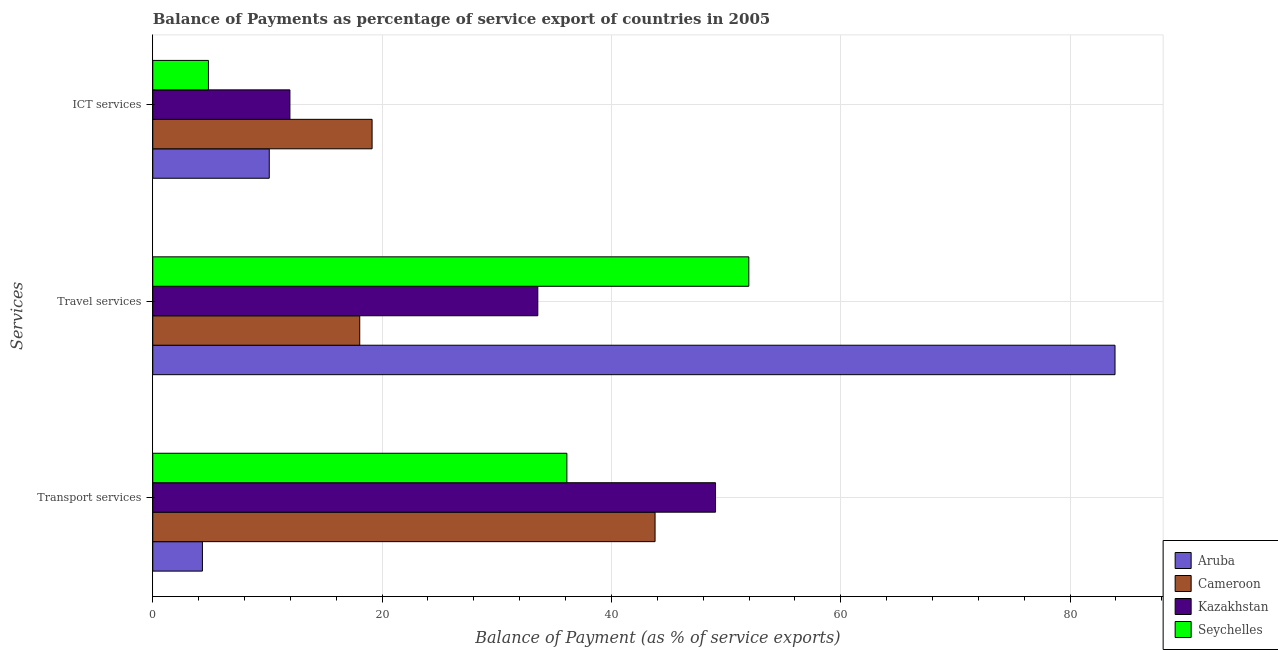How many different coloured bars are there?
Provide a short and direct response. 4. Are the number of bars per tick equal to the number of legend labels?
Your answer should be compact. Yes. Are the number of bars on each tick of the Y-axis equal?
Ensure brevity in your answer.  Yes. How many bars are there on the 1st tick from the top?
Provide a succinct answer. 4. What is the label of the 2nd group of bars from the top?
Provide a succinct answer. Travel services. What is the balance of payment of travel services in Cameroon?
Your response must be concise. 18.05. Across all countries, what is the maximum balance of payment of transport services?
Offer a very short reply. 49.08. Across all countries, what is the minimum balance of payment of ict services?
Your answer should be very brief. 4.85. In which country was the balance of payment of travel services maximum?
Keep it short and to the point. Aruba. In which country was the balance of payment of transport services minimum?
Provide a short and direct response. Aruba. What is the total balance of payment of ict services in the graph?
Give a very brief answer. 46.1. What is the difference between the balance of payment of travel services in Kazakhstan and that in Aruba?
Provide a succinct answer. -50.34. What is the difference between the balance of payment of travel services in Cameroon and the balance of payment of transport services in Kazakhstan?
Your answer should be very brief. -31.03. What is the average balance of payment of travel services per country?
Your answer should be very brief. 46.88. What is the difference between the balance of payment of ict services and balance of payment of transport services in Kazakhstan?
Make the answer very short. -37.12. What is the ratio of the balance of payment of travel services in Kazakhstan to that in Seychelles?
Your response must be concise. 0.65. Is the balance of payment of travel services in Kazakhstan less than that in Seychelles?
Your response must be concise. Yes. What is the difference between the highest and the second highest balance of payment of transport services?
Your answer should be very brief. 5.27. What is the difference between the highest and the lowest balance of payment of transport services?
Your response must be concise. 44.75. What does the 1st bar from the top in ICT services represents?
Your answer should be very brief. Seychelles. What does the 3rd bar from the bottom in Transport services represents?
Provide a succinct answer. Kazakhstan. Is it the case that in every country, the sum of the balance of payment of transport services and balance of payment of travel services is greater than the balance of payment of ict services?
Make the answer very short. Yes. How many bars are there?
Give a very brief answer. 12. Are all the bars in the graph horizontal?
Provide a succinct answer. Yes. What is the difference between two consecutive major ticks on the X-axis?
Provide a short and direct response. 20. Are the values on the major ticks of X-axis written in scientific E-notation?
Ensure brevity in your answer.  No. Does the graph contain grids?
Your answer should be very brief. Yes. Where does the legend appear in the graph?
Your response must be concise. Bottom right. How are the legend labels stacked?
Offer a very short reply. Vertical. What is the title of the graph?
Your answer should be compact. Balance of Payments as percentage of service export of countries in 2005. Does "Somalia" appear as one of the legend labels in the graph?
Your response must be concise. No. What is the label or title of the X-axis?
Your answer should be very brief. Balance of Payment (as % of service exports). What is the label or title of the Y-axis?
Offer a terse response. Services. What is the Balance of Payment (as % of service exports) of Aruba in Transport services?
Offer a very short reply. 4.33. What is the Balance of Payment (as % of service exports) of Cameroon in Transport services?
Keep it short and to the point. 43.8. What is the Balance of Payment (as % of service exports) of Kazakhstan in Transport services?
Provide a succinct answer. 49.08. What is the Balance of Payment (as % of service exports) of Seychelles in Transport services?
Your response must be concise. 36.11. What is the Balance of Payment (as % of service exports) of Aruba in Travel services?
Your answer should be compact. 83.92. What is the Balance of Payment (as % of service exports) in Cameroon in Travel services?
Offer a terse response. 18.05. What is the Balance of Payment (as % of service exports) of Kazakhstan in Travel services?
Ensure brevity in your answer.  33.58. What is the Balance of Payment (as % of service exports) in Seychelles in Travel services?
Give a very brief answer. 51.98. What is the Balance of Payment (as % of service exports) in Aruba in ICT services?
Ensure brevity in your answer.  10.16. What is the Balance of Payment (as % of service exports) of Cameroon in ICT services?
Your answer should be compact. 19.13. What is the Balance of Payment (as % of service exports) of Kazakhstan in ICT services?
Provide a succinct answer. 11.96. What is the Balance of Payment (as % of service exports) of Seychelles in ICT services?
Keep it short and to the point. 4.85. Across all Services, what is the maximum Balance of Payment (as % of service exports) of Aruba?
Provide a succinct answer. 83.92. Across all Services, what is the maximum Balance of Payment (as % of service exports) in Cameroon?
Offer a terse response. 43.8. Across all Services, what is the maximum Balance of Payment (as % of service exports) in Kazakhstan?
Provide a short and direct response. 49.08. Across all Services, what is the maximum Balance of Payment (as % of service exports) in Seychelles?
Provide a succinct answer. 51.98. Across all Services, what is the minimum Balance of Payment (as % of service exports) of Aruba?
Provide a short and direct response. 4.33. Across all Services, what is the minimum Balance of Payment (as % of service exports) in Cameroon?
Ensure brevity in your answer.  18.05. Across all Services, what is the minimum Balance of Payment (as % of service exports) of Kazakhstan?
Provide a succinct answer. 11.96. Across all Services, what is the minimum Balance of Payment (as % of service exports) in Seychelles?
Make the answer very short. 4.85. What is the total Balance of Payment (as % of service exports) in Aruba in the graph?
Make the answer very short. 98.4. What is the total Balance of Payment (as % of service exports) of Cameroon in the graph?
Give a very brief answer. 80.98. What is the total Balance of Payment (as % of service exports) in Kazakhstan in the graph?
Offer a very short reply. 94.62. What is the total Balance of Payment (as % of service exports) of Seychelles in the graph?
Offer a very short reply. 92.95. What is the difference between the Balance of Payment (as % of service exports) in Aruba in Transport services and that in Travel services?
Your answer should be very brief. -79.59. What is the difference between the Balance of Payment (as % of service exports) of Cameroon in Transport services and that in Travel services?
Your answer should be compact. 25.76. What is the difference between the Balance of Payment (as % of service exports) in Seychelles in Transport services and that in Travel services?
Keep it short and to the point. -15.87. What is the difference between the Balance of Payment (as % of service exports) in Aruba in Transport services and that in ICT services?
Your answer should be very brief. -5.83. What is the difference between the Balance of Payment (as % of service exports) of Cameroon in Transport services and that in ICT services?
Provide a short and direct response. 24.68. What is the difference between the Balance of Payment (as % of service exports) of Kazakhstan in Transport services and that in ICT services?
Your answer should be compact. 37.12. What is the difference between the Balance of Payment (as % of service exports) of Seychelles in Transport services and that in ICT services?
Ensure brevity in your answer.  31.26. What is the difference between the Balance of Payment (as % of service exports) in Aruba in Travel services and that in ICT services?
Your answer should be compact. 73.76. What is the difference between the Balance of Payment (as % of service exports) of Cameroon in Travel services and that in ICT services?
Give a very brief answer. -1.08. What is the difference between the Balance of Payment (as % of service exports) in Kazakhstan in Travel services and that in ICT services?
Provide a short and direct response. 21.62. What is the difference between the Balance of Payment (as % of service exports) of Seychelles in Travel services and that in ICT services?
Offer a terse response. 47.12. What is the difference between the Balance of Payment (as % of service exports) of Aruba in Transport services and the Balance of Payment (as % of service exports) of Cameroon in Travel services?
Provide a succinct answer. -13.72. What is the difference between the Balance of Payment (as % of service exports) of Aruba in Transport services and the Balance of Payment (as % of service exports) of Kazakhstan in Travel services?
Your response must be concise. -29.25. What is the difference between the Balance of Payment (as % of service exports) of Aruba in Transport services and the Balance of Payment (as % of service exports) of Seychelles in Travel services?
Your answer should be compact. -47.65. What is the difference between the Balance of Payment (as % of service exports) in Cameroon in Transport services and the Balance of Payment (as % of service exports) in Kazakhstan in Travel services?
Provide a succinct answer. 10.23. What is the difference between the Balance of Payment (as % of service exports) of Cameroon in Transport services and the Balance of Payment (as % of service exports) of Seychelles in Travel services?
Give a very brief answer. -8.18. What is the difference between the Balance of Payment (as % of service exports) of Kazakhstan in Transport services and the Balance of Payment (as % of service exports) of Seychelles in Travel services?
Your answer should be compact. -2.9. What is the difference between the Balance of Payment (as % of service exports) of Aruba in Transport services and the Balance of Payment (as % of service exports) of Cameroon in ICT services?
Make the answer very short. -14.8. What is the difference between the Balance of Payment (as % of service exports) of Aruba in Transport services and the Balance of Payment (as % of service exports) of Kazakhstan in ICT services?
Your response must be concise. -7.63. What is the difference between the Balance of Payment (as % of service exports) of Aruba in Transport services and the Balance of Payment (as % of service exports) of Seychelles in ICT services?
Provide a short and direct response. -0.53. What is the difference between the Balance of Payment (as % of service exports) of Cameroon in Transport services and the Balance of Payment (as % of service exports) of Kazakhstan in ICT services?
Provide a short and direct response. 31.84. What is the difference between the Balance of Payment (as % of service exports) of Cameroon in Transport services and the Balance of Payment (as % of service exports) of Seychelles in ICT services?
Offer a very short reply. 38.95. What is the difference between the Balance of Payment (as % of service exports) of Kazakhstan in Transport services and the Balance of Payment (as % of service exports) of Seychelles in ICT services?
Provide a short and direct response. 44.22. What is the difference between the Balance of Payment (as % of service exports) in Aruba in Travel services and the Balance of Payment (as % of service exports) in Cameroon in ICT services?
Provide a succinct answer. 64.79. What is the difference between the Balance of Payment (as % of service exports) in Aruba in Travel services and the Balance of Payment (as % of service exports) in Kazakhstan in ICT services?
Ensure brevity in your answer.  71.96. What is the difference between the Balance of Payment (as % of service exports) of Aruba in Travel services and the Balance of Payment (as % of service exports) of Seychelles in ICT services?
Your answer should be very brief. 79.06. What is the difference between the Balance of Payment (as % of service exports) of Cameroon in Travel services and the Balance of Payment (as % of service exports) of Kazakhstan in ICT services?
Your response must be concise. 6.09. What is the difference between the Balance of Payment (as % of service exports) in Cameroon in Travel services and the Balance of Payment (as % of service exports) in Seychelles in ICT services?
Provide a short and direct response. 13.19. What is the difference between the Balance of Payment (as % of service exports) in Kazakhstan in Travel services and the Balance of Payment (as % of service exports) in Seychelles in ICT services?
Provide a short and direct response. 28.72. What is the average Balance of Payment (as % of service exports) of Aruba per Services?
Give a very brief answer. 32.8. What is the average Balance of Payment (as % of service exports) in Cameroon per Services?
Ensure brevity in your answer.  26.99. What is the average Balance of Payment (as % of service exports) in Kazakhstan per Services?
Provide a succinct answer. 31.54. What is the average Balance of Payment (as % of service exports) in Seychelles per Services?
Give a very brief answer. 30.98. What is the difference between the Balance of Payment (as % of service exports) of Aruba and Balance of Payment (as % of service exports) of Cameroon in Transport services?
Keep it short and to the point. -39.47. What is the difference between the Balance of Payment (as % of service exports) of Aruba and Balance of Payment (as % of service exports) of Kazakhstan in Transport services?
Your response must be concise. -44.75. What is the difference between the Balance of Payment (as % of service exports) of Aruba and Balance of Payment (as % of service exports) of Seychelles in Transport services?
Make the answer very short. -31.78. What is the difference between the Balance of Payment (as % of service exports) in Cameroon and Balance of Payment (as % of service exports) in Kazakhstan in Transport services?
Offer a terse response. -5.27. What is the difference between the Balance of Payment (as % of service exports) of Cameroon and Balance of Payment (as % of service exports) of Seychelles in Transport services?
Provide a succinct answer. 7.69. What is the difference between the Balance of Payment (as % of service exports) of Kazakhstan and Balance of Payment (as % of service exports) of Seychelles in Transport services?
Your answer should be very brief. 12.96. What is the difference between the Balance of Payment (as % of service exports) of Aruba and Balance of Payment (as % of service exports) of Cameroon in Travel services?
Provide a succinct answer. 65.87. What is the difference between the Balance of Payment (as % of service exports) of Aruba and Balance of Payment (as % of service exports) of Kazakhstan in Travel services?
Your answer should be very brief. 50.34. What is the difference between the Balance of Payment (as % of service exports) of Aruba and Balance of Payment (as % of service exports) of Seychelles in Travel services?
Give a very brief answer. 31.94. What is the difference between the Balance of Payment (as % of service exports) of Cameroon and Balance of Payment (as % of service exports) of Kazakhstan in Travel services?
Offer a very short reply. -15.53. What is the difference between the Balance of Payment (as % of service exports) of Cameroon and Balance of Payment (as % of service exports) of Seychelles in Travel services?
Your answer should be compact. -33.93. What is the difference between the Balance of Payment (as % of service exports) of Kazakhstan and Balance of Payment (as % of service exports) of Seychelles in Travel services?
Make the answer very short. -18.4. What is the difference between the Balance of Payment (as % of service exports) in Aruba and Balance of Payment (as % of service exports) in Cameroon in ICT services?
Your answer should be compact. -8.97. What is the difference between the Balance of Payment (as % of service exports) of Aruba and Balance of Payment (as % of service exports) of Kazakhstan in ICT services?
Give a very brief answer. -1.8. What is the difference between the Balance of Payment (as % of service exports) in Aruba and Balance of Payment (as % of service exports) in Seychelles in ICT services?
Provide a succinct answer. 5.3. What is the difference between the Balance of Payment (as % of service exports) in Cameroon and Balance of Payment (as % of service exports) in Kazakhstan in ICT services?
Provide a succinct answer. 7.17. What is the difference between the Balance of Payment (as % of service exports) of Cameroon and Balance of Payment (as % of service exports) of Seychelles in ICT services?
Ensure brevity in your answer.  14.27. What is the difference between the Balance of Payment (as % of service exports) of Kazakhstan and Balance of Payment (as % of service exports) of Seychelles in ICT services?
Ensure brevity in your answer.  7.11. What is the ratio of the Balance of Payment (as % of service exports) of Aruba in Transport services to that in Travel services?
Provide a short and direct response. 0.05. What is the ratio of the Balance of Payment (as % of service exports) in Cameroon in Transport services to that in Travel services?
Make the answer very short. 2.43. What is the ratio of the Balance of Payment (as % of service exports) of Kazakhstan in Transport services to that in Travel services?
Give a very brief answer. 1.46. What is the ratio of the Balance of Payment (as % of service exports) of Seychelles in Transport services to that in Travel services?
Your answer should be compact. 0.69. What is the ratio of the Balance of Payment (as % of service exports) in Aruba in Transport services to that in ICT services?
Give a very brief answer. 0.43. What is the ratio of the Balance of Payment (as % of service exports) of Cameroon in Transport services to that in ICT services?
Make the answer very short. 2.29. What is the ratio of the Balance of Payment (as % of service exports) of Kazakhstan in Transport services to that in ICT services?
Offer a very short reply. 4.1. What is the ratio of the Balance of Payment (as % of service exports) in Seychelles in Transport services to that in ICT services?
Provide a short and direct response. 7.44. What is the ratio of the Balance of Payment (as % of service exports) in Aruba in Travel services to that in ICT services?
Your answer should be compact. 8.26. What is the ratio of the Balance of Payment (as % of service exports) of Cameroon in Travel services to that in ICT services?
Make the answer very short. 0.94. What is the ratio of the Balance of Payment (as % of service exports) in Kazakhstan in Travel services to that in ICT services?
Ensure brevity in your answer.  2.81. What is the ratio of the Balance of Payment (as % of service exports) of Seychelles in Travel services to that in ICT services?
Offer a very short reply. 10.71. What is the difference between the highest and the second highest Balance of Payment (as % of service exports) in Aruba?
Provide a succinct answer. 73.76. What is the difference between the highest and the second highest Balance of Payment (as % of service exports) of Cameroon?
Make the answer very short. 24.68. What is the difference between the highest and the second highest Balance of Payment (as % of service exports) of Kazakhstan?
Provide a short and direct response. 15.5. What is the difference between the highest and the second highest Balance of Payment (as % of service exports) of Seychelles?
Provide a short and direct response. 15.87. What is the difference between the highest and the lowest Balance of Payment (as % of service exports) of Aruba?
Provide a short and direct response. 79.59. What is the difference between the highest and the lowest Balance of Payment (as % of service exports) of Cameroon?
Offer a very short reply. 25.76. What is the difference between the highest and the lowest Balance of Payment (as % of service exports) in Kazakhstan?
Give a very brief answer. 37.12. What is the difference between the highest and the lowest Balance of Payment (as % of service exports) of Seychelles?
Give a very brief answer. 47.12. 